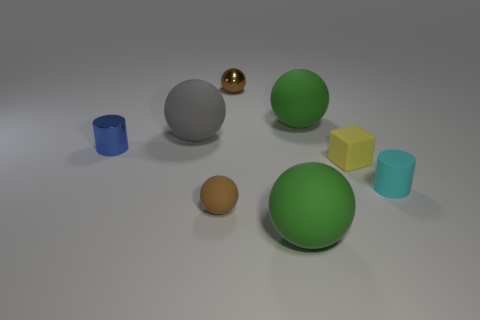Subtract 2 spheres. How many spheres are left? 3 Subtract all gray spheres. How many spheres are left? 4 Subtract all small rubber spheres. How many spheres are left? 4 Subtract all purple balls. Subtract all green cylinders. How many balls are left? 5 Add 1 blue shiny spheres. How many objects exist? 9 Subtract all cubes. How many objects are left? 7 Add 7 tiny brown shiny things. How many tiny brown shiny things are left? 8 Add 8 tiny gray shiny objects. How many tiny gray shiny objects exist? 8 Subtract 0 cyan balls. How many objects are left? 8 Subtract all small metal balls. Subtract all gray spheres. How many objects are left? 6 